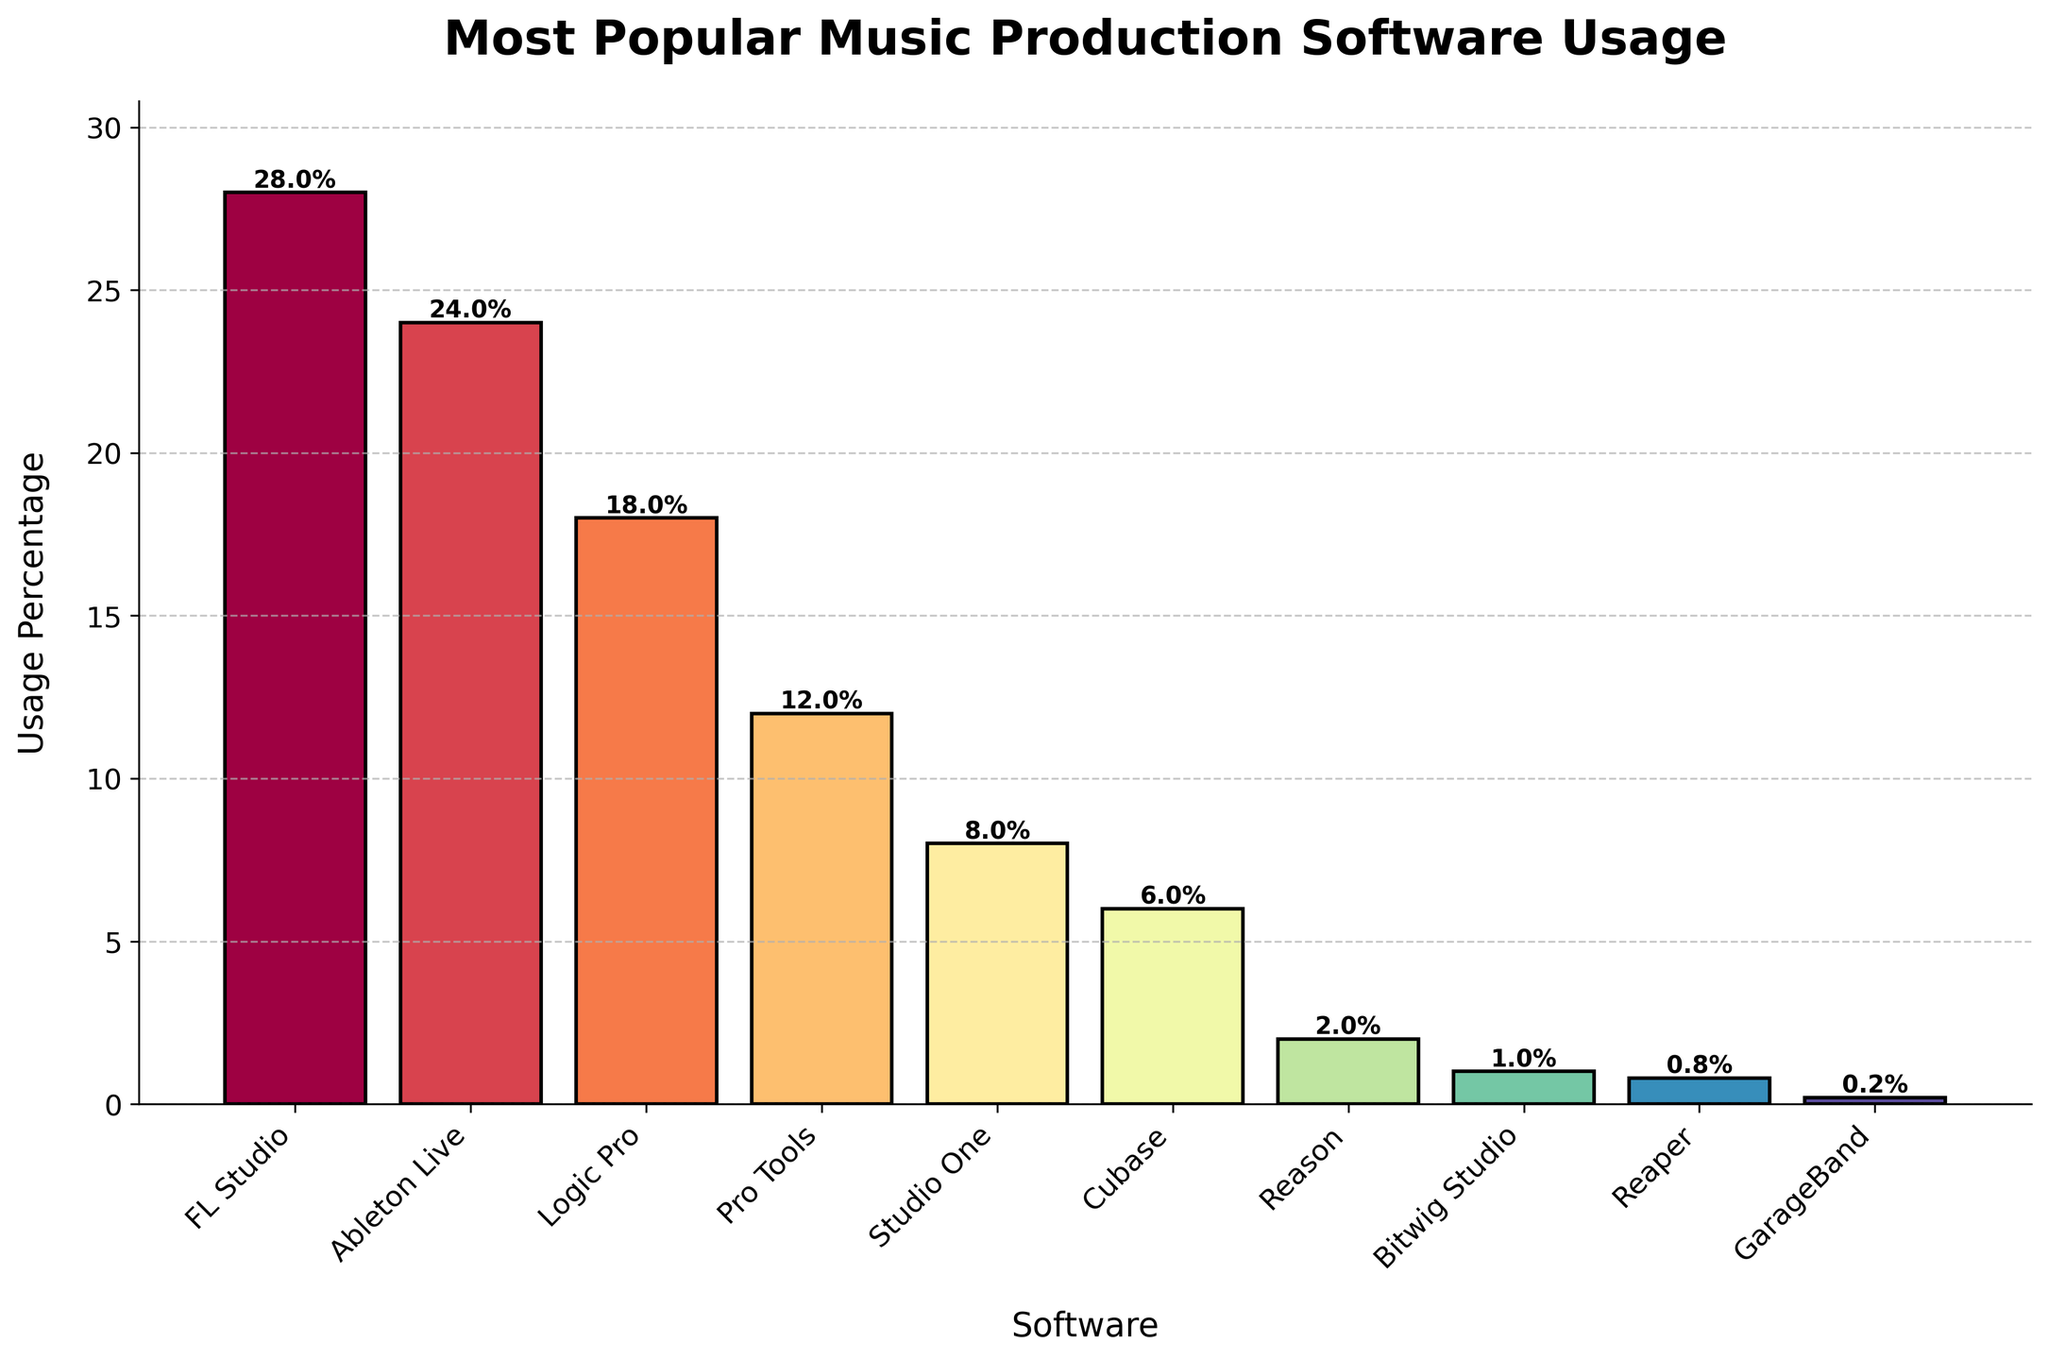What's the most popular music production software based on the usage percentage? The figure shows that FL Studio has the highest bar, indicating it has the greatest usage percentage among all the music production software listed.
Answer: FL Studio Which software has less than 10% usage? By looking at the height of the bars and the percentage labels, Studio One, Cubase, Reason, Bitwig Studio, Reaper, and GarageBand all have usage percentages less than 10%.
Answer: Studio One, Cubase, Reason, Bitwig Studio, Reaper, GarageBand Excluding the top three software, what's the combined usage percentage of the remaining ones? Subtract the sum of the usage percentages of FL Studio (28%), Ableton Live (24%), and Logic Pro (18%) from 100%. Calculations: 28 + 24 + 18 = 70, and 100 - 70 = 30.
Answer: 30% Which software has approximately three times the usage of Cubase? By examining the bar heights and labels, Studio One has a usage percentage (8%) that is approximately three times higher than Cubase (6%).
Answer: Studio One What is the difference in usage percentage between Logic Pro and Pro Tools? The figure shows that Logic Pro has an 18% usage, and Pro Tools has a 12% usage. The difference is 18 - 12 = 6.
Answer: 6% What colors represent FL Studio and GarageBand? FL Studio is represented by the first bar which has a color from the Spectral colormap with a gradient around red. GarageBand is the last bar, with a color at the very end of the Spectral color gradient, which is around purple.
Answer: Red (FL Studio), Purple (GarageBand) Which software has the closest usage percentage to the median of the set? The median is the middle value in the ordered list of usage percentages: 0.2, 0.8, 1, 2, 6, 8, 12, 18, 24, 28. The median is (8+12)/2 = 10. Studio One, with a usage percentage of 8%, is the closest to the median value.
Answer: Studio One Name two softwares whose combined usage percentage equals that of Logic Pro. Logic Pro has an 18% usage rate. Pro Tools (12%) and Reason (2%) combined equal 14%, while Ableton Live (24% - too high). Cubase (6%) and Studio One (8%) combined equals 14% also. However, Pro Tools (12%) and Reaper (0.8%) comes closest, totaling 12.8%, and are the best nearby combination.
Answer: Pro Tools and Reason Is Bitwig Studio more or less popular than Reason? Bitwig Studio has a 1% usage percentage, while Reason has a 2% usage percentage. Since 1% is less than 2%, Bitwig Studio is less popular than Reason.
Answer: Less popular Which software have usage percentages greater than 20%? The figure shows that there are only two bars with usage percentages greater than 20%: FL Studio (28%) and Ableton Live (24%).
Answer: FL Studio, Ableton Live 